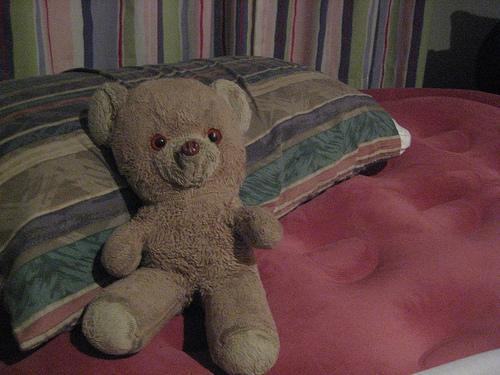How many bears are there?
Give a very brief answer. 1. 